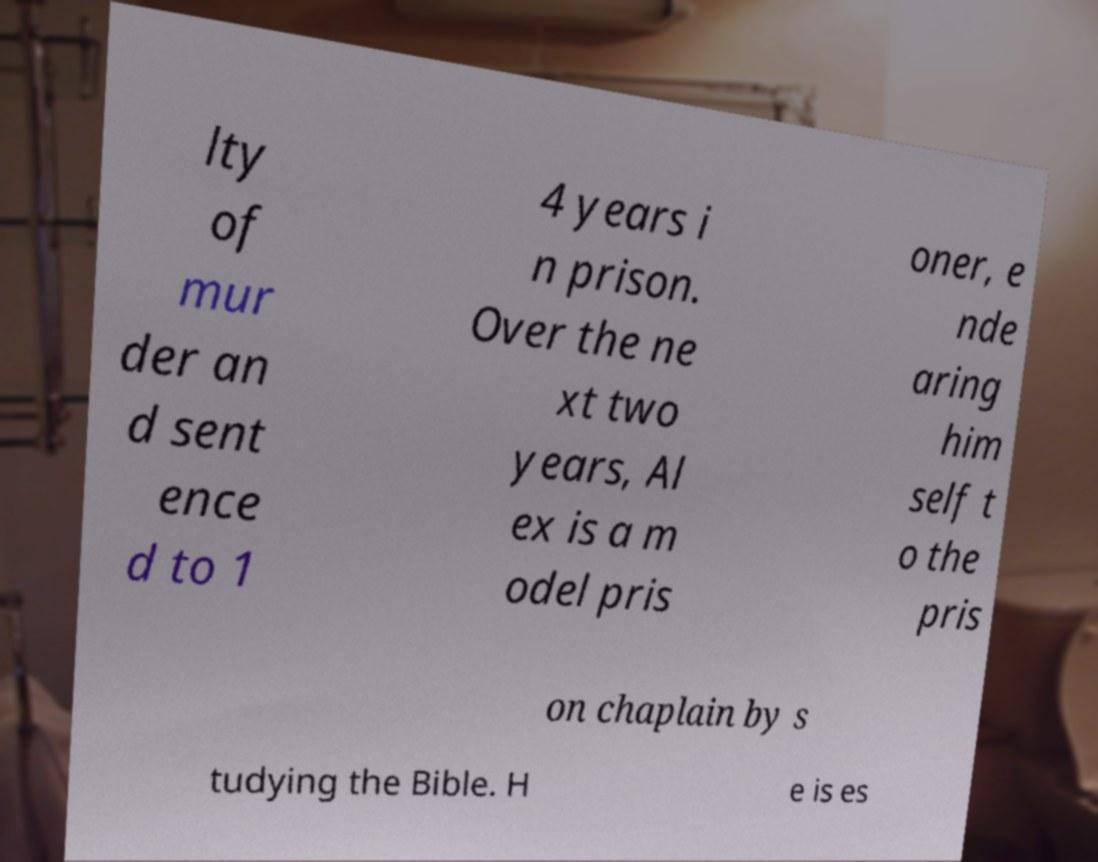Can you accurately transcribe the text from the provided image for me? lty of mur der an d sent ence d to 1 4 years i n prison. Over the ne xt two years, Al ex is a m odel pris oner, e nde aring him self t o the pris on chaplain by s tudying the Bible. H e is es 